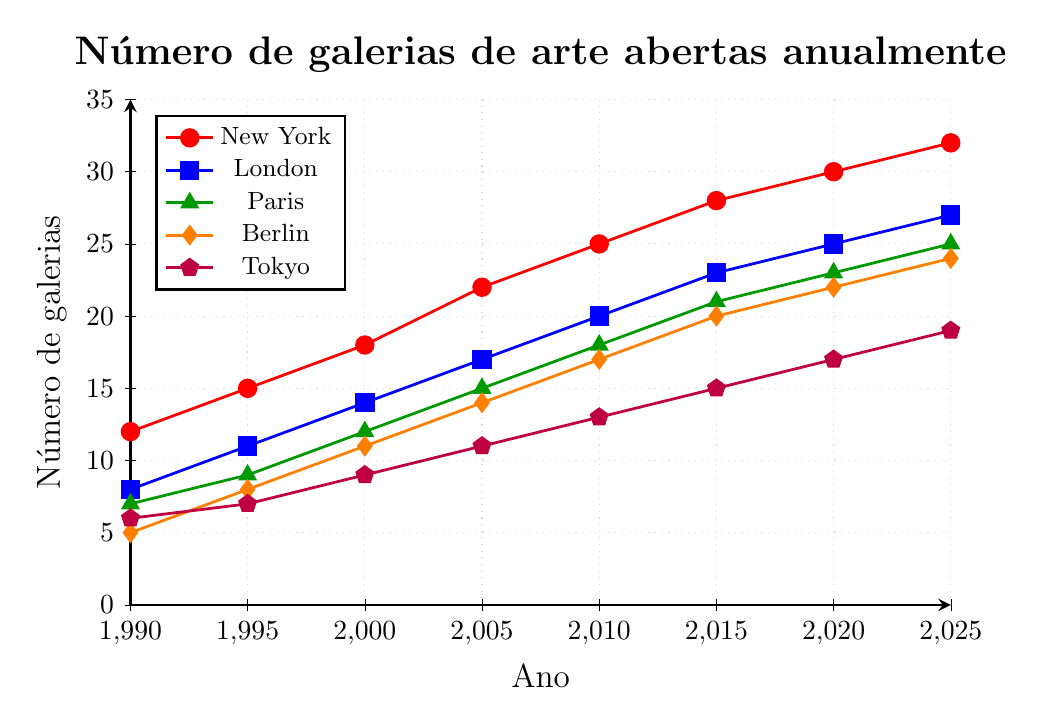Qual cidade teve o maior aumento no número de novas galerias de 1990 a 2025? Primeiro, encontramos os valores de 1990 e 2025 para cada cidade. Em seguida, calculamos a diferença: Nova York (32-12=20), Londres (27-8=19), Paris (25-7=18), Berlim (24-5=19), Tóquio (19-6=13). Nova York teve o maior aumento.
Answer: Nova York Em que ano Londres superou Paris no número de novas galerias? Nós observamos os valores de Londres e Paris ao longo dos anos. Em 2000, Londres teve 14 e Paris 12. Então, foi em 2000 que Londres superou Paris.
Answer: 2000 Em qual cidade o número de novas galerias em 1990 é menor do que o número de novas galerias em 2010? Observando os números em 1990 e 2010: Nova York (12<25), Londres (8<20), Paris (7<18), Berlim (5<17), Tóquio (6<13). Todas as cidades têm o número de novas galerias em 1990 menor que em 2010.
Answer: Todas Quantas novas galerias foram abertas no total nas cinco cidades em 2015? Somamos os valores de 2015 para todas as cidades: Nova York (28), Londres (23), Paris (21), Berlim (20), Tóquio (15). Total = 28 + 23 + 21 + 20 + 15 = 107.
Answer: 107 Qual cidade tinha o menor número de novas galerias em 1995? Verificamos os valores de 1995 para cada cidade: Nova York (15), Londres (11), Paris (9), Berlim (8), Tóquio (7). A cidade com o menor número em 1995 é Tóquio.
Answer: Tóquio Quantas galerias Nova York abriu a mais que Berlim em 2005? Comparando os valores para 2005: Nova York (22), Berlim (14). A diferença é 22 - 14 = 8.
Answer: 8 Entre 1990 e 2000, qual cidade teve a maior média de novas galerias por ano? Calculamos a média de novas galerias para cada cidade entre 1990 e 2000: Nova York [(12+15+18)/3 = 15], Londres [(8+11+14)/3 = 11], Paris [(7+9+12)/3 = 9.33], Berlim [(5+8+11)/3 = 8], Tóquio [(6+7+9)/3 = 7.33]. Nova York tem a maior média.
Answer: Nova York 